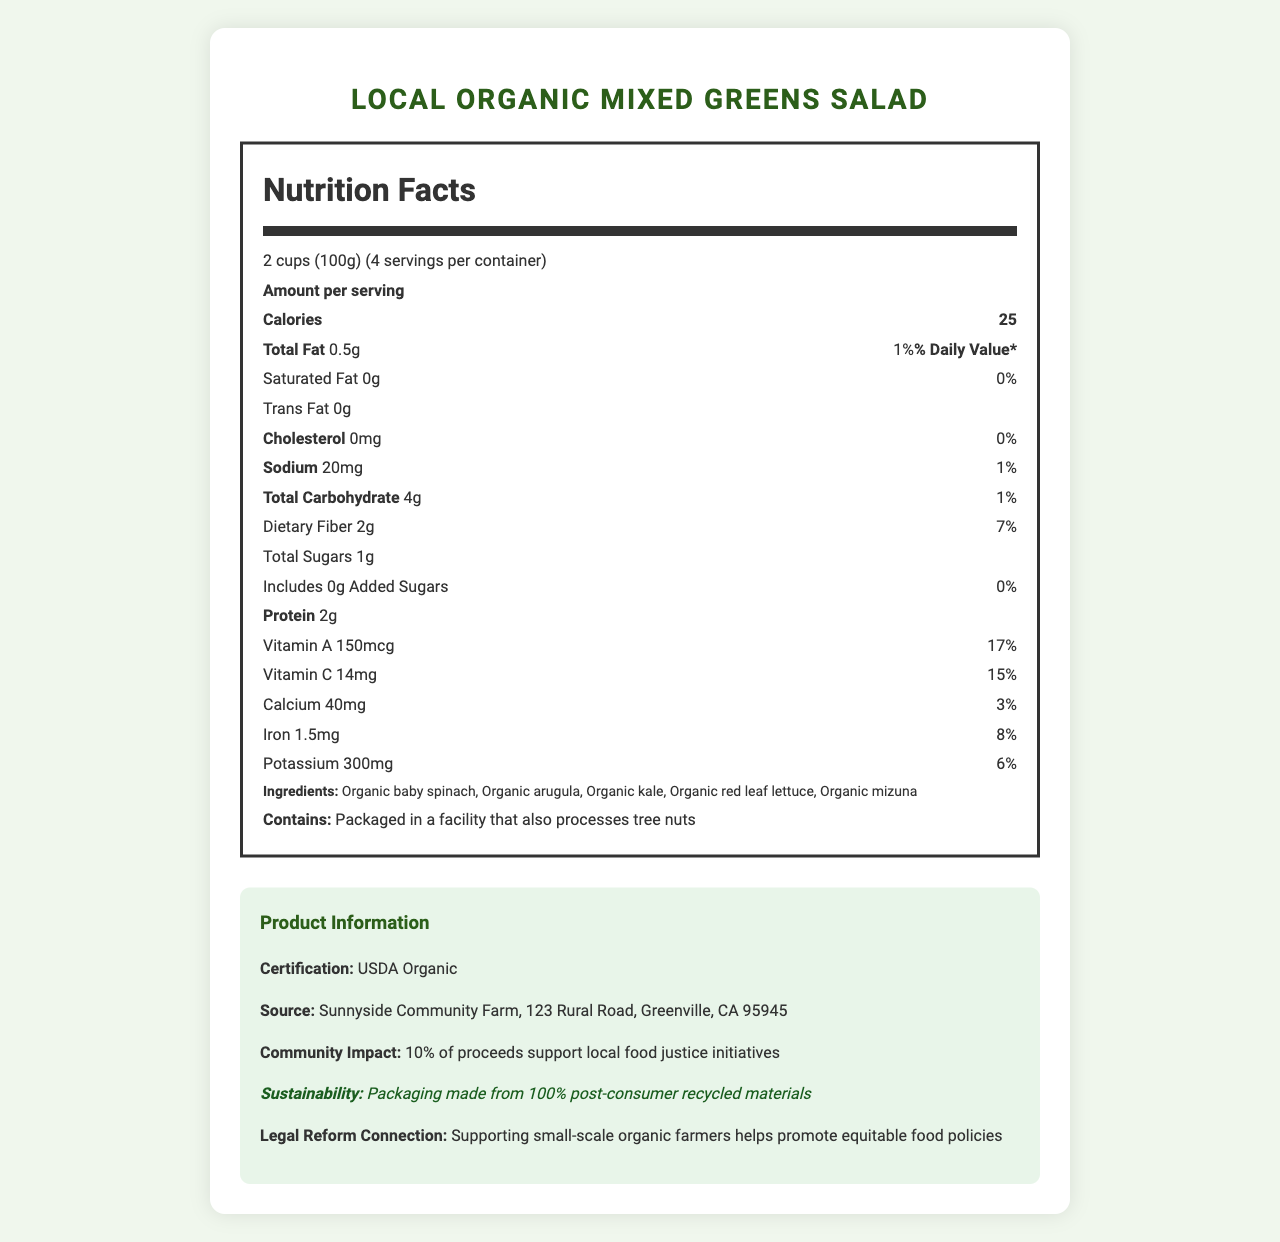what is the serving size for the Local Organic Mixed Greens Salad? The serving size is explicitly stated as "2 cups (100g)" in the nutrition facts section.
Answer: 2 cups (100g) how many calories are there per serving? The document clearly states that there are 25 calories per serving.
Answer: 25 calories which vitamins are listed in the nutrition facts? The document mentions both Vitamin A (150mcg) and Vitamin C (14mg) with their respective daily values.
Answer: Vitamin A and Vitamin C what percentage of daily iron does one serving provide? The nutrition facts mention that one serving provides 8% of the daily value of iron.
Answer: 8% list the organic greens included in the salad mix These ingredients are listed under the ingredients section of the document.
Answer: Organic baby spinach, Organic arugula, Organic kale, Organic red leaf lettuce, Organic mizuna what is the farm source for the greens? The farm source is mentioned as Sunnyside Community Farm, located at 123 Rural Road, Greenville, CA 95945.
Answer: Sunnyside Community Farm does the product contain any added sugars? (yes/no) The document states that there are 0 grams of added sugars in the product.
Answer: No what health benefit does the fiber content in the salad provide? The dietary fiber content of 2g per serving provides 7% of the daily value, as stated in the nutrition facts.
Answer: 7% of daily value what is the sustainability note related to the packaging of the product? The sustainability note highlights that the packaging is made from 100% post-consumer recycled materials.
Answer: Packaging made from 100% post-consumer recycled materials what percentage of the proceeds goes to local food justice initiatives? The community impact section of the document states that 10% of the proceeds support local food justice initiatives.
Answer: 10% which of the following is a nutrient found in the salad? A. Vitamin D B. Vitamin C C. Vitamin B12 D. Vitamin K The nutrition facts mention Vitamin C, but there is no mention of Vitamin D, B12, or K.
Answer: B. Vitamin C the salad provides how much potassium per serving? I. 200mg II. 300mg III. 400mg The document clearly states that each serving provides 300mg of potassium.
Answer: II. 300mg is the total carbohydrate amount higher or lower than the sodium amount? The total carbohydrate amount is 4g, which is higher than the sodium amount of 20mg.
Answer: Higher describe the product's connection to legal reform. The document connects this product to legal reform by stating that supporting small-scale organic farmers helps promote equitable food policies.
Answer: Supporting small-scale organic farmers helps promote equitable food policies. how many different types of organic lettuces are included in the salad mix? The document lists Organic baby spinach, Organic arugula, Organic kale, Organic red leaf lettuce, and Organic mizuna, but the exact count of lettuces cannot be discerned as not all are lettuces.
Answer: Cannot be determined Summarize the entire document's information in a few sentences. The nutrient facts include detailed breakdowns of macro and micronutrients, sourcing information, ingredients, and the product's broader social and environmental impacts.
Answer: The document provides comprehensive nutritional facts for the Local Organic Mixed Greens Salad, highlighting low calories and fats, significant vitamins, and minerals. It sources the produce from Sunnyside Community Farm, with a focus on sustainability and community impact. The product is USDA Organic certified and supports local food justice initiatives by donating 10% of proceeds. It's packaged in eco-friendly materials and promotes equitable food policies through support of small-scale farmers. 